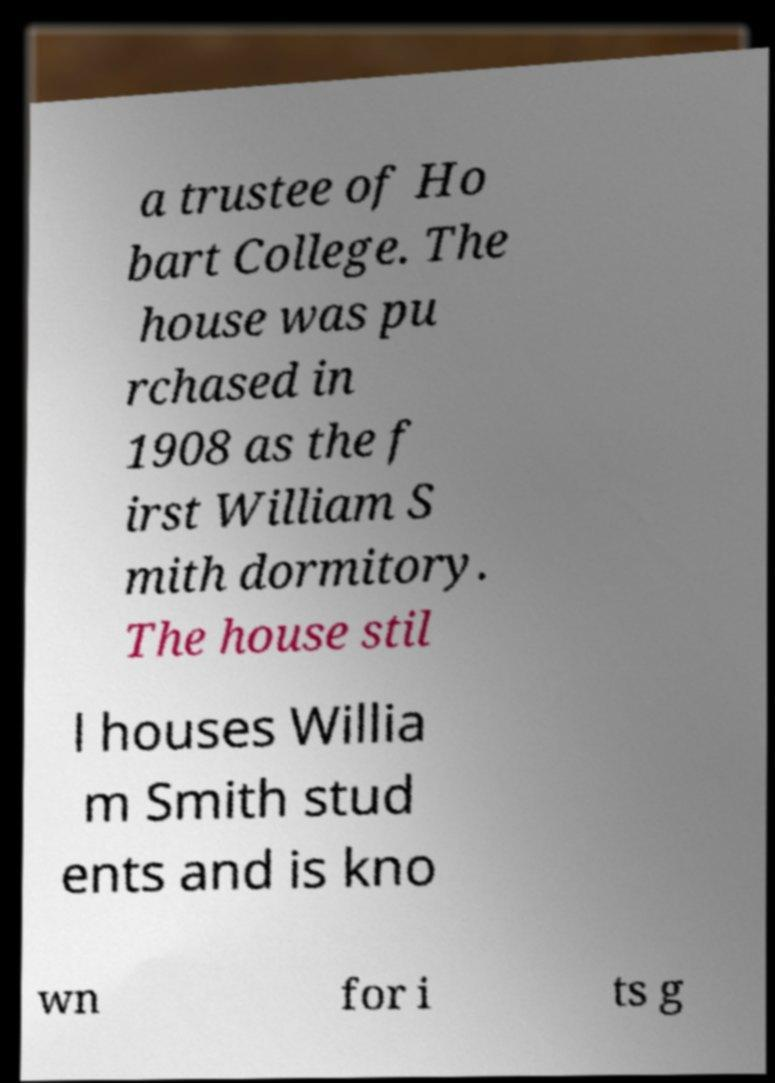Can you accurately transcribe the text from the provided image for me? a trustee of Ho bart College. The house was pu rchased in 1908 as the f irst William S mith dormitory. The house stil l houses Willia m Smith stud ents and is kno wn for i ts g 